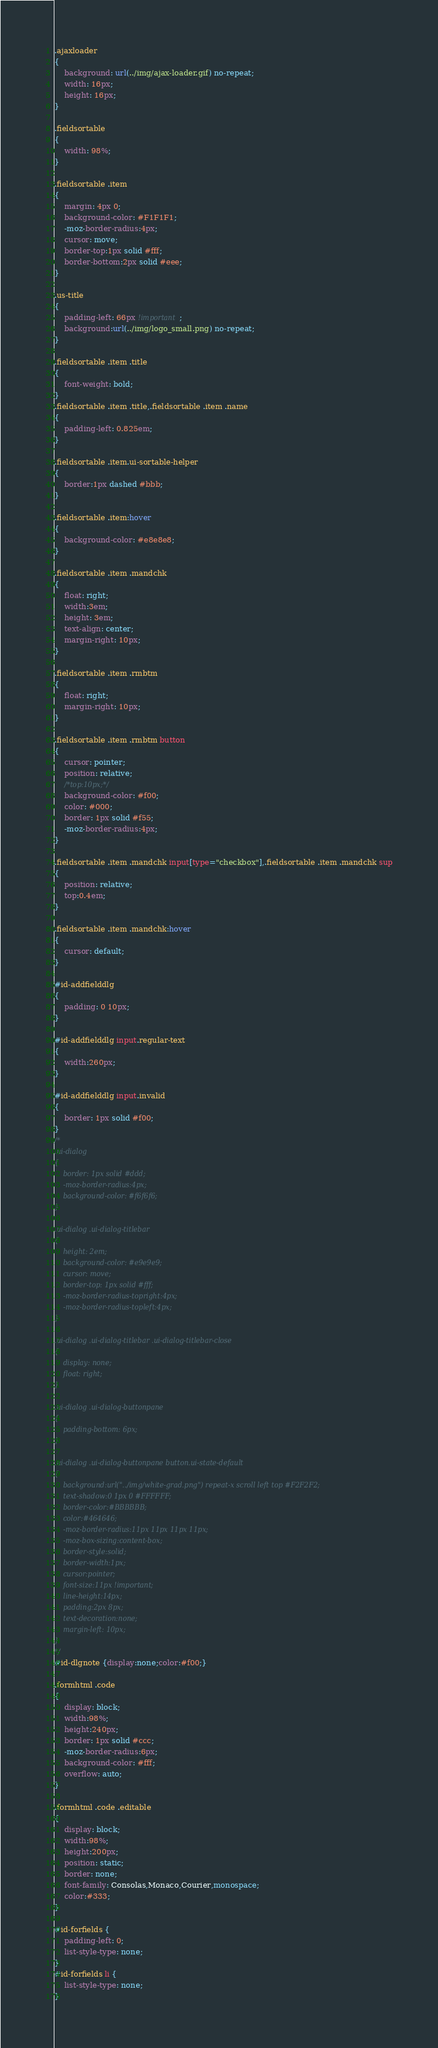Convert code to text. <code><loc_0><loc_0><loc_500><loc_500><_CSS_>.ajaxloader
{
    background: url(../img/ajax-loader.gif) no-repeat;
    width: 16px;
    height: 16px;
}

.fieldsortable
{
    width: 98%;
}

.fieldsortable .item
{
    margin: 4px 0;
    background-color: #F1F1F1;
    -moz-border-radius:4px;
    cursor: move;
    border-top:1px solid #fff;
    border-bottom:2px solid #eee;
}

.us-title
{
    padding-left: 66px !important;
    background:url(../img/logo_small.png) no-repeat;
}

.fieldsortable .item .title
{
    font-weight: bold;
}
.fieldsortable .item .title,.fieldsortable .item .name
{
    padding-left: 0.825em;
}

.fieldsortable .item.ui-sortable-helper
{
    border:1px dashed #bbb;
}

.fieldsortable .item:hover
{
    background-color: #e8e8e8;
}

.fieldsortable .item .mandchk
{
    float: right;
    width:3em;
    height: 3em;
    text-align: center;
    margin-right: 10px;
}

.fieldsortable .item .rmbtm
{
    float: right;
    margin-right: 10px;
}

.fieldsortable .item .rmbtm button
{
    cursor: pointer;
    position: relative;
    /*top:10px;*/
    background-color: #f00;
    color: #000;
    border: 1px solid #f55;
    -moz-border-radius:4px;
}

.fieldsortable .item .mandchk input[type="checkbox"],.fieldsortable .item .mandchk sup
{
    position: relative;
    top:0.4em;
}

.fieldsortable .item .mandchk:hover
{
    cursor: default;
}

#id-addfielddlg
{
    padding: 0 10px;
}

#id-addfielddlg input.regular-text
{
    width:260px;
}

#id-addfielddlg input.invalid
{
    border: 1px solid #f00;
}
/*
.ui-dialog
{
    border: 1px solid #ddd;
    -moz-border-radius:4px;
    background-color: #f6f6f6;
}

.ui-dialog .ui-dialog-titlebar
{
    height: 2em;
    background-color: #e9e9e9;
    cursor: move;
    border-top: 1px solid #fff;
    -moz-border-radius-topright:4px;
    -moz-border-radius-topleft:4px;
}

.ui-dialog .ui-dialog-titlebar .ui-dialog-titlebar-close
{
    display: none;
    float: right;
}

.ui-dialog .ui-dialog-buttonpane
{
    padding-bottom: 6px;
}

.ui-dialog .ui-dialog-buttonpane button.ui-state-default
{
    background:url("../img/white-grad.png") repeat-x scroll left top #F2F2F2;
    text-shadow:0 1px 0 #FFFFFF;
    border-color:#BBBBBB;
    color:#464646;
    -moz-border-radius:11px 11px 11px 11px;
    -moz-box-sizing:content-box;
    border-style:solid;
    border-width:1px;
    cursor:pointer;
    font-size:11px !important;
    line-height:14px;
    padding:2px 8px;
    text-decoration:none;
    margin-left: 10px;
}
*/
#id-dlgnote {display:none;color:#f00;}

.formhtml .code
{
    display: block;
    width:98%;
    height:240px;
    border: 1px solid #ccc;
    -moz-border-radius:6px;
    background-color: #fff;
    overflow: auto;
}

.formhtml .code .editable
{
    display: block;
    width:98%;
    height:200px;
    position: static;
    border: none;
    font-family: Consolas,Monaco,Courier,monospace;
    color:#333;
}

#id-forfields {
    padding-left: 0;
    list-style-type: none;
}
#id-forfields li {
    list-style-type: none;
}
</code> 